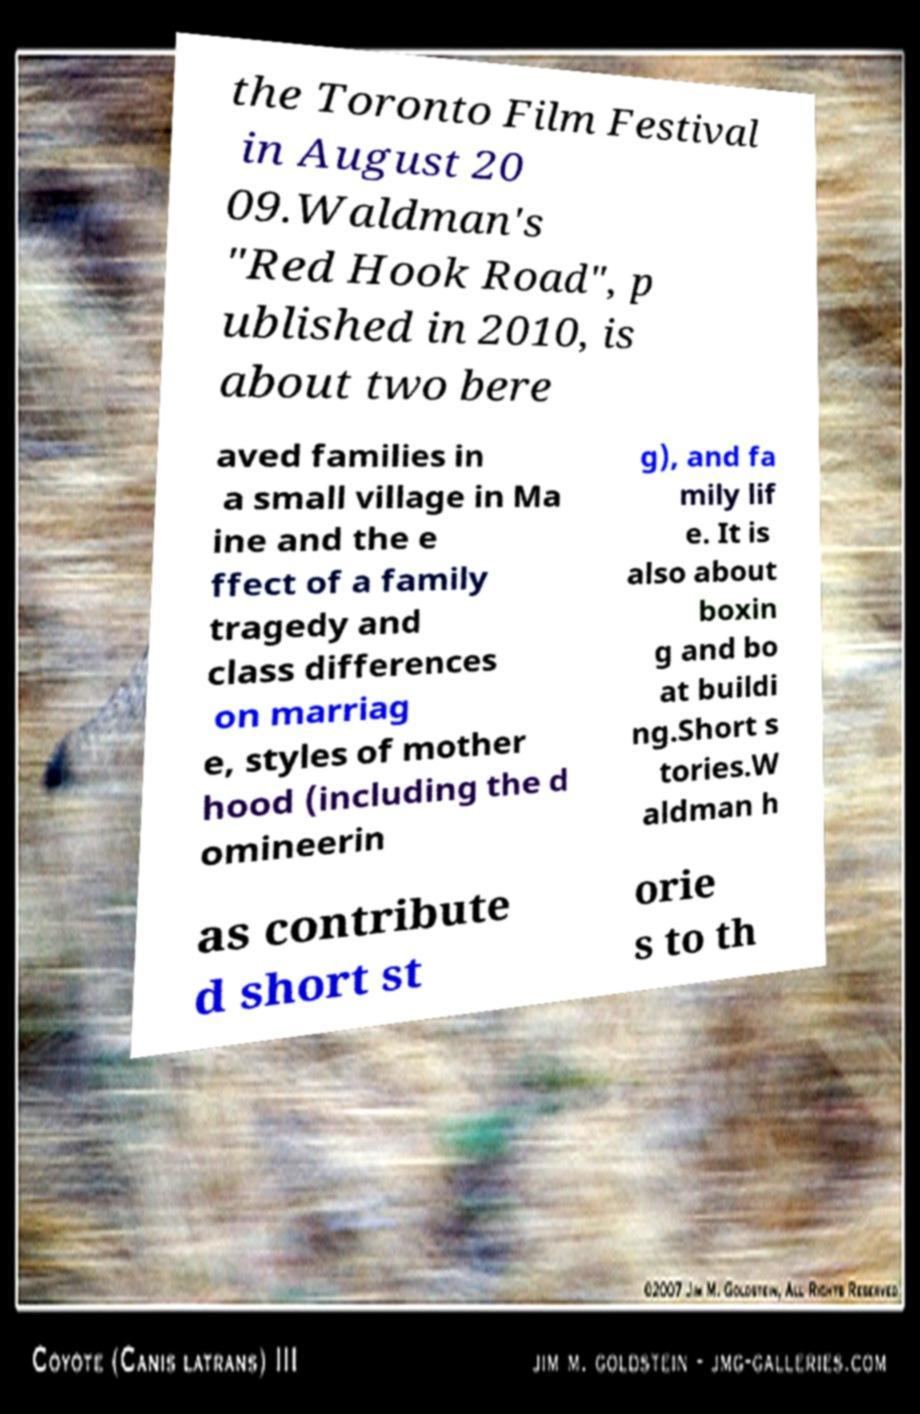I need the written content from this picture converted into text. Can you do that? the Toronto Film Festival in August 20 09.Waldman's "Red Hook Road", p ublished in 2010, is about two bere aved families in a small village in Ma ine and the e ffect of a family tragedy and class differences on marriag e, styles of mother hood (including the d omineerin g), and fa mily lif e. It is also about boxin g and bo at buildi ng.Short s tories.W aldman h as contribute d short st orie s to th 